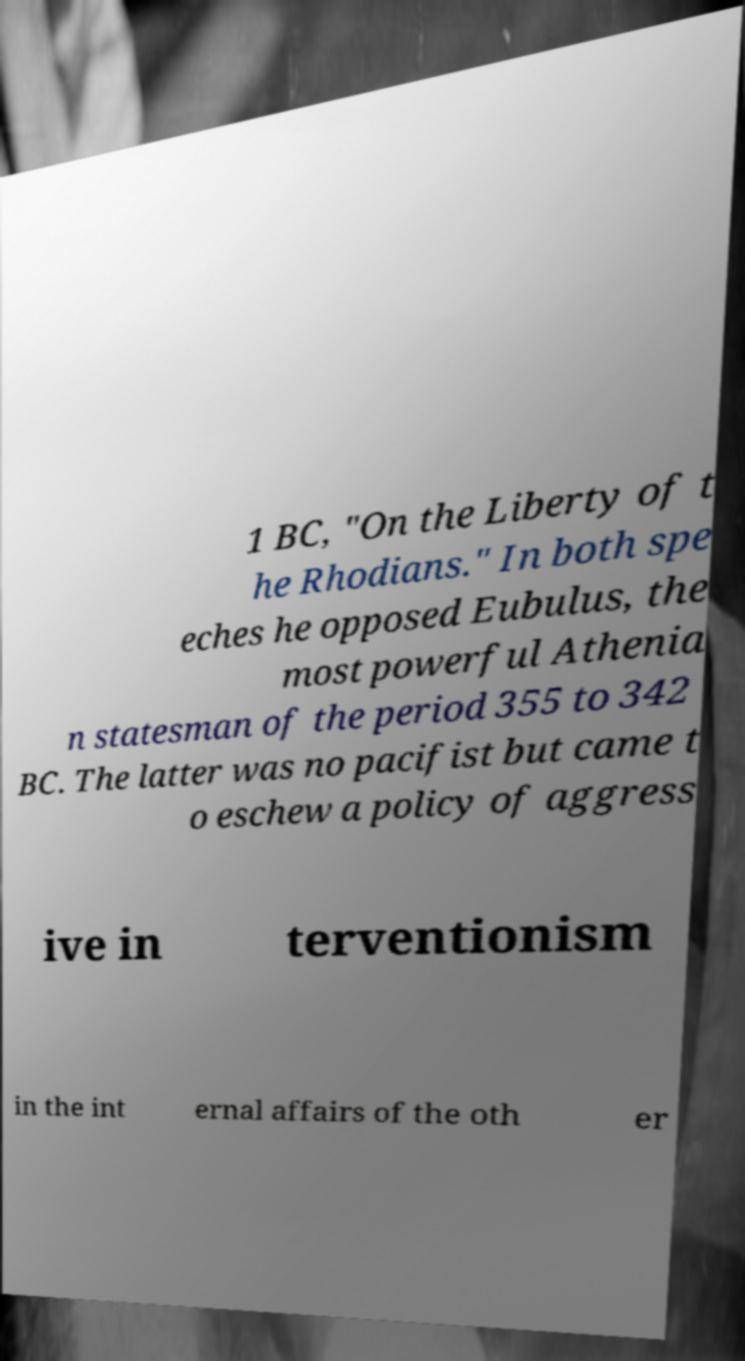Can you read and provide the text displayed in the image?This photo seems to have some interesting text. Can you extract and type it out for me? 1 BC, "On the Liberty of t he Rhodians." In both spe eches he opposed Eubulus, the most powerful Athenia n statesman of the period 355 to 342 BC. The latter was no pacifist but came t o eschew a policy of aggress ive in terventionism in the int ernal affairs of the oth er 